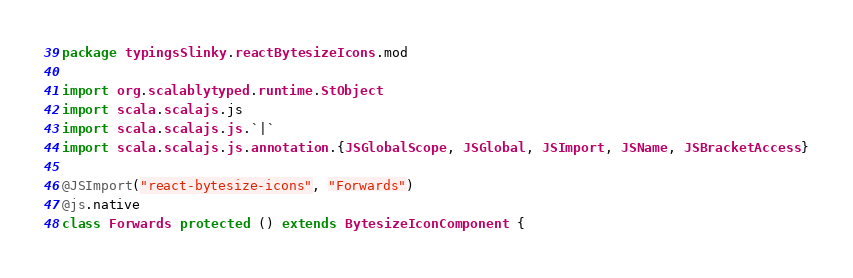Convert code to text. <code><loc_0><loc_0><loc_500><loc_500><_Scala_>package typingsSlinky.reactBytesizeIcons.mod

import org.scalablytyped.runtime.StObject
import scala.scalajs.js
import scala.scalajs.js.`|`
import scala.scalajs.js.annotation.{JSGlobalScope, JSGlobal, JSImport, JSName, JSBracketAccess}

@JSImport("react-bytesize-icons", "Forwards")
@js.native
class Forwards protected () extends BytesizeIconComponent {</code> 